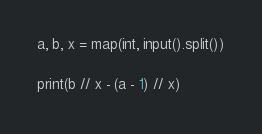<code> <loc_0><loc_0><loc_500><loc_500><_Python_>a, b, x = map(int, input().split())

print(b // x - (a - 1) // x)</code> 